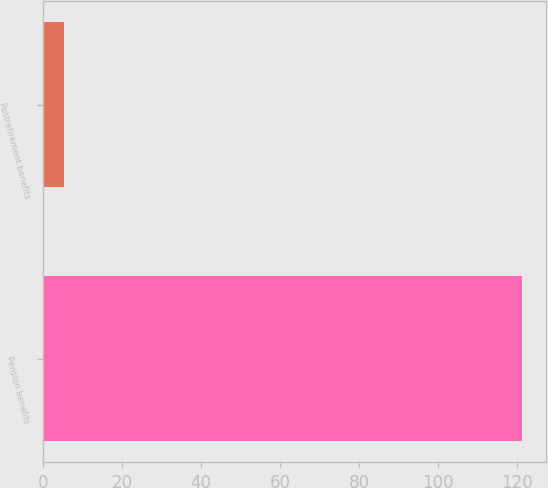Convert chart to OTSL. <chart><loc_0><loc_0><loc_500><loc_500><bar_chart><fcel>Pension benefits<fcel>Postretirement benefits<nl><fcel>121.2<fcel>5.3<nl></chart> 